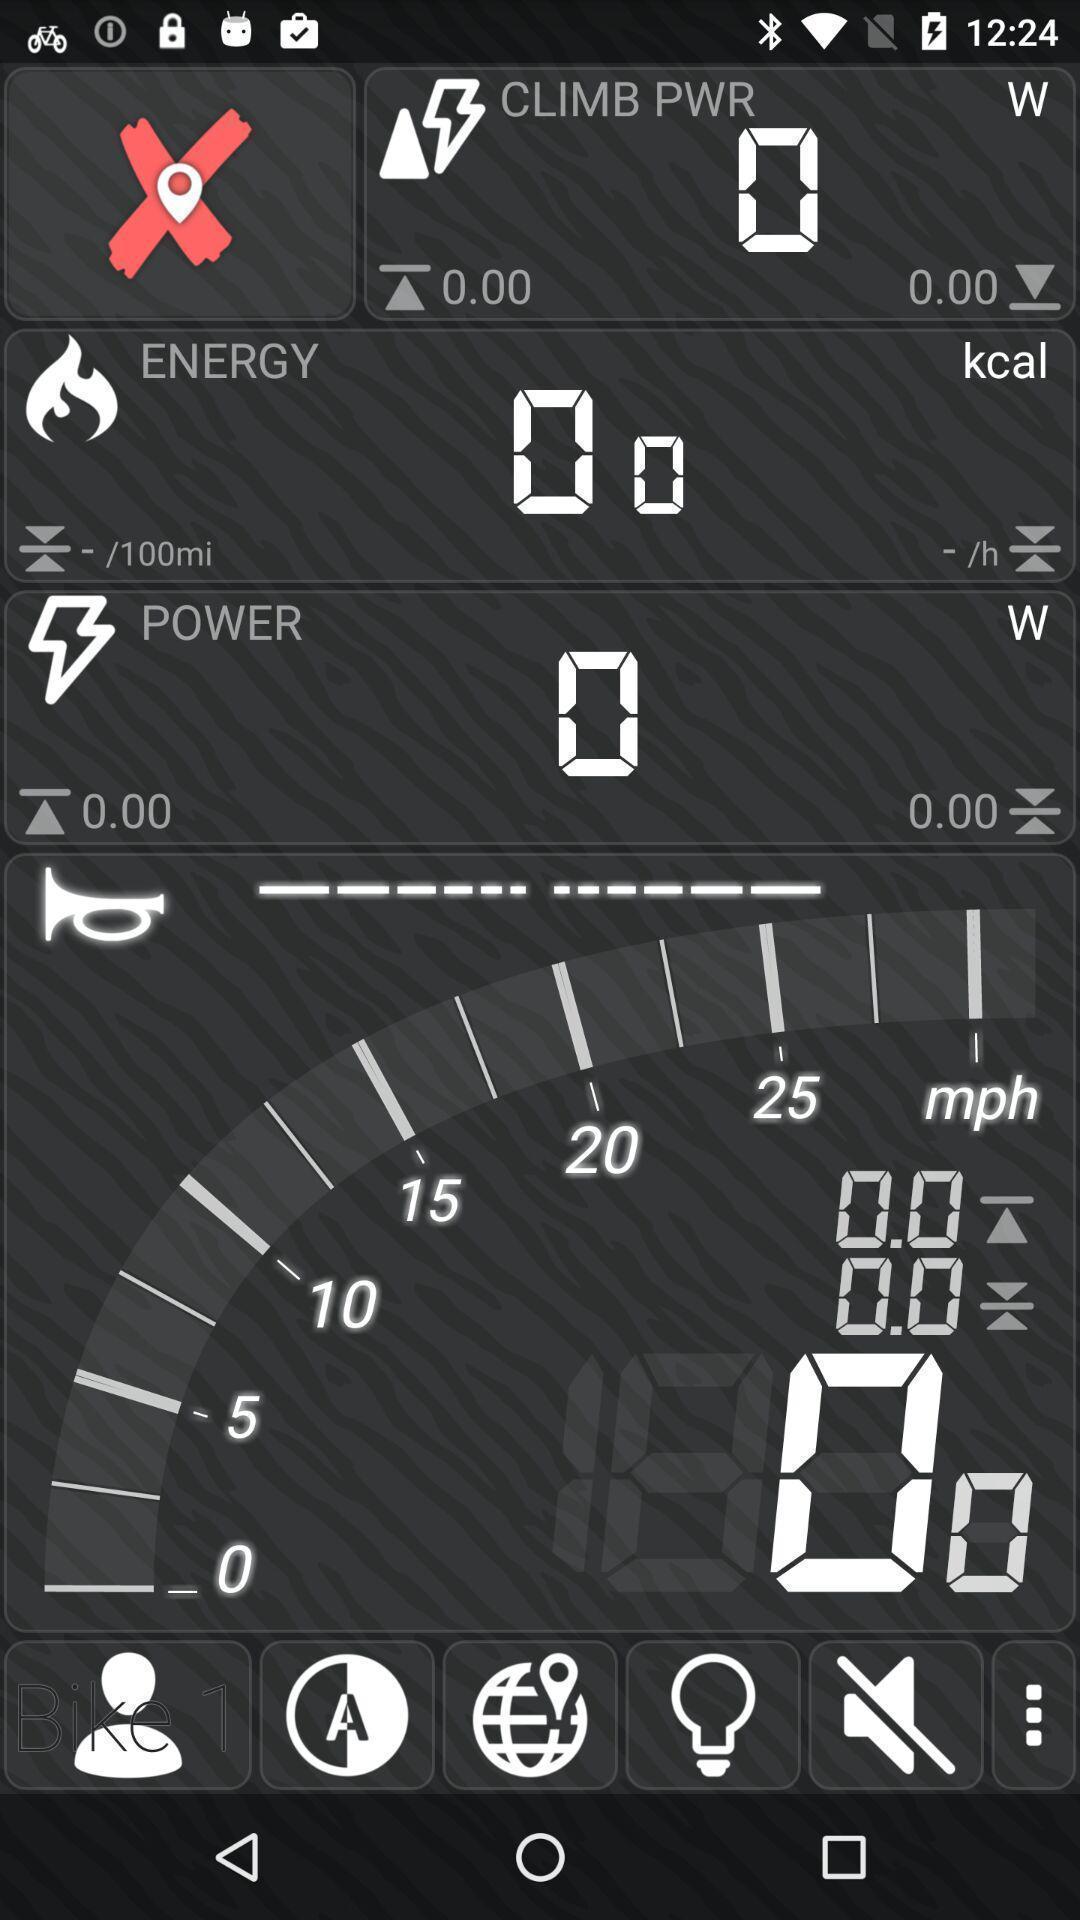Explain the elements present in this screenshot. Page record your rides. 